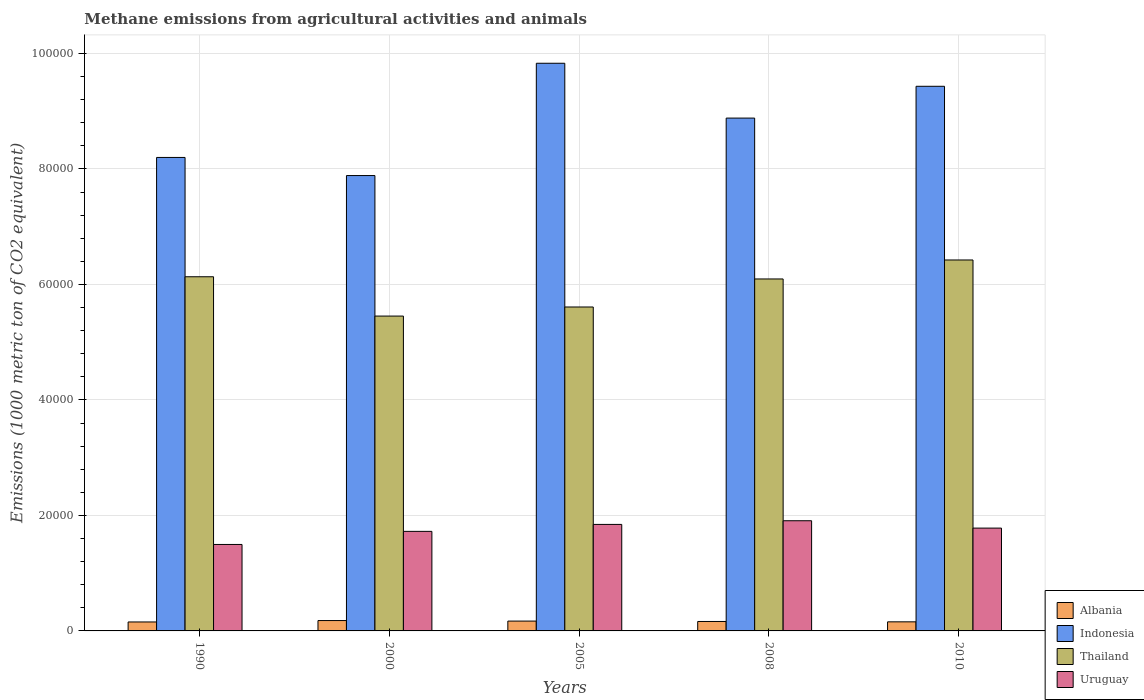How many different coloured bars are there?
Make the answer very short. 4. Are the number of bars per tick equal to the number of legend labels?
Provide a short and direct response. Yes. Are the number of bars on each tick of the X-axis equal?
Your answer should be very brief. Yes. How many bars are there on the 2nd tick from the left?
Your answer should be very brief. 4. How many bars are there on the 2nd tick from the right?
Your response must be concise. 4. What is the label of the 2nd group of bars from the left?
Provide a short and direct response. 2000. What is the amount of methane emitted in Thailand in 2005?
Offer a terse response. 5.61e+04. Across all years, what is the maximum amount of methane emitted in Albania?
Ensure brevity in your answer.  1794.6. Across all years, what is the minimum amount of methane emitted in Albania?
Ensure brevity in your answer.  1550.9. In which year was the amount of methane emitted in Uruguay minimum?
Keep it short and to the point. 1990. What is the total amount of methane emitted in Indonesia in the graph?
Offer a terse response. 4.42e+05. What is the difference between the amount of methane emitted in Thailand in 2005 and that in 2010?
Your answer should be very brief. -8141. What is the difference between the amount of methane emitted in Albania in 2010 and the amount of methane emitted in Thailand in 2005?
Keep it short and to the point. -5.45e+04. What is the average amount of methane emitted in Uruguay per year?
Provide a short and direct response. 1.75e+04. In the year 1990, what is the difference between the amount of methane emitted in Uruguay and amount of methane emitted in Albania?
Make the answer very short. 1.34e+04. In how many years, is the amount of methane emitted in Thailand greater than 80000 1000 metric ton?
Provide a succinct answer. 0. What is the ratio of the amount of methane emitted in Indonesia in 2000 to that in 2010?
Make the answer very short. 0.84. Is the amount of methane emitted in Albania in 2005 less than that in 2008?
Your response must be concise. No. What is the difference between the highest and the second highest amount of methane emitted in Albania?
Make the answer very short. 91.7. What is the difference between the highest and the lowest amount of methane emitted in Uruguay?
Make the answer very short. 4108.2. In how many years, is the amount of methane emitted in Albania greater than the average amount of methane emitted in Albania taken over all years?
Your answer should be compact. 2. Is the sum of the amount of methane emitted in Albania in 2005 and 2010 greater than the maximum amount of methane emitted in Uruguay across all years?
Your response must be concise. No. What does the 1st bar from the left in 2010 represents?
Offer a very short reply. Albania. What does the 4th bar from the right in 1990 represents?
Your response must be concise. Albania. Is it the case that in every year, the sum of the amount of methane emitted in Uruguay and amount of methane emitted in Albania is greater than the amount of methane emitted in Indonesia?
Ensure brevity in your answer.  No. How many bars are there?
Your answer should be compact. 20. How many years are there in the graph?
Give a very brief answer. 5. Does the graph contain grids?
Provide a succinct answer. Yes. How many legend labels are there?
Offer a terse response. 4. How are the legend labels stacked?
Your answer should be compact. Vertical. What is the title of the graph?
Offer a very short reply. Methane emissions from agricultural activities and animals. Does "Switzerland" appear as one of the legend labels in the graph?
Ensure brevity in your answer.  No. What is the label or title of the Y-axis?
Your answer should be compact. Emissions (1000 metric ton of CO2 equivalent). What is the Emissions (1000 metric ton of CO2 equivalent) in Albania in 1990?
Make the answer very short. 1550.9. What is the Emissions (1000 metric ton of CO2 equivalent) of Indonesia in 1990?
Ensure brevity in your answer.  8.20e+04. What is the Emissions (1000 metric ton of CO2 equivalent) of Thailand in 1990?
Keep it short and to the point. 6.13e+04. What is the Emissions (1000 metric ton of CO2 equivalent) of Uruguay in 1990?
Make the answer very short. 1.50e+04. What is the Emissions (1000 metric ton of CO2 equivalent) in Albania in 2000?
Make the answer very short. 1794.6. What is the Emissions (1000 metric ton of CO2 equivalent) of Indonesia in 2000?
Make the answer very short. 7.89e+04. What is the Emissions (1000 metric ton of CO2 equivalent) of Thailand in 2000?
Your answer should be very brief. 5.45e+04. What is the Emissions (1000 metric ton of CO2 equivalent) in Uruguay in 2000?
Make the answer very short. 1.72e+04. What is the Emissions (1000 metric ton of CO2 equivalent) of Albania in 2005?
Your answer should be compact. 1702.9. What is the Emissions (1000 metric ton of CO2 equivalent) in Indonesia in 2005?
Provide a short and direct response. 9.83e+04. What is the Emissions (1000 metric ton of CO2 equivalent) of Thailand in 2005?
Your answer should be compact. 5.61e+04. What is the Emissions (1000 metric ton of CO2 equivalent) in Uruguay in 2005?
Offer a terse response. 1.84e+04. What is the Emissions (1000 metric ton of CO2 equivalent) of Albania in 2008?
Offer a very short reply. 1635.8. What is the Emissions (1000 metric ton of CO2 equivalent) in Indonesia in 2008?
Your response must be concise. 8.88e+04. What is the Emissions (1000 metric ton of CO2 equivalent) in Thailand in 2008?
Your answer should be compact. 6.10e+04. What is the Emissions (1000 metric ton of CO2 equivalent) in Uruguay in 2008?
Give a very brief answer. 1.91e+04. What is the Emissions (1000 metric ton of CO2 equivalent) in Albania in 2010?
Your answer should be very brief. 1574.1. What is the Emissions (1000 metric ton of CO2 equivalent) in Indonesia in 2010?
Your answer should be compact. 9.43e+04. What is the Emissions (1000 metric ton of CO2 equivalent) in Thailand in 2010?
Keep it short and to the point. 6.42e+04. What is the Emissions (1000 metric ton of CO2 equivalent) of Uruguay in 2010?
Your response must be concise. 1.78e+04. Across all years, what is the maximum Emissions (1000 metric ton of CO2 equivalent) in Albania?
Provide a short and direct response. 1794.6. Across all years, what is the maximum Emissions (1000 metric ton of CO2 equivalent) in Indonesia?
Make the answer very short. 9.83e+04. Across all years, what is the maximum Emissions (1000 metric ton of CO2 equivalent) of Thailand?
Your response must be concise. 6.42e+04. Across all years, what is the maximum Emissions (1000 metric ton of CO2 equivalent) in Uruguay?
Ensure brevity in your answer.  1.91e+04. Across all years, what is the minimum Emissions (1000 metric ton of CO2 equivalent) in Albania?
Give a very brief answer. 1550.9. Across all years, what is the minimum Emissions (1000 metric ton of CO2 equivalent) in Indonesia?
Your answer should be compact. 7.89e+04. Across all years, what is the minimum Emissions (1000 metric ton of CO2 equivalent) of Thailand?
Keep it short and to the point. 5.45e+04. Across all years, what is the minimum Emissions (1000 metric ton of CO2 equivalent) of Uruguay?
Your response must be concise. 1.50e+04. What is the total Emissions (1000 metric ton of CO2 equivalent) of Albania in the graph?
Your answer should be compact. 8258.3. What is the total Emissions (1000 metric ton of CO2 equivalent) of Indonesia in the graph?
Offer a terse response. 4.42e+05. What is the total Emissions (1000 metric ton of CO2 equivalent) in Thailand in the graph?
Keep it short and to the point. 2.97e+05. What is the total Emissions (1000 metric ton of CO2 equivalent) of Uruguay in the graph?
Provide a succinct answer. 8.75e+04. What is the difference between the Emissions (1000 metric ton of CO2 equivalent) in Albania in 1990 and that in 2000?
Offer a very short reply. -243.7. What is the difference between the Emissions (1000 metric ton of CO2 equivalent) of Indonesia in 1990 and that in 2000?
Your answer should be very brief. 3136.2. What is the difference between the Emissions (1000 metric ton of CO2 equivalent) in Thailand in 1990 and that in 2000?
Ensure brevity in your answer.  6808.4. What is the difference between the Emissions (1000 metric ton of CO2 equivalent) of Uruguay in 1990 and that in 2000?
Make the answer very short. -2267.7. What is the difference between the Emissions (1000 metric ton of CO2 equivalent) in Albania in 1990 and that in 2005?
Ensure brevity in your answer.  -152. What is the difference between the Emissions (1000 metric ton of CO2 equivalent) in Indonesia in 1990 and that in 2005?
Give a very brief answer. -1.63e+04. What is the difference between the Emissions (1000 metric ton of CO2 equivalent) in Thailand in 1990 and that in 2005?
Provide a succinct answer. 5235.2. What is the difference between the Emissions (1000 metric ton of CO2 equivalent) in Uruguay in 1990 and that in 2005?
Keep it short and to the point. -3472.5. What is the difference between the Emissions (1000 metric ton of CO2 equivalent) in Albania in 1990 and that in 2008?
Give a very brief answer. -84.9. What is the difference between the Emissions (1000 metric ton of CO2 equivalent) of Indonesia in 1990 and that in 2008?
Your response must be concise. -6814.3. What is the difference between the Emissions (1000 metric ton of CO2 equivalent) in Thailand in 1990 and that in 2008?
Offer a very short reply. 381.9. What is the difference between the Emissions (1000 metric ton of CO2 equivalent) of Uruguay in 1990 and that in 2008?
Offer a terse response. -4108.2. What is the difference between the Emissions (1000 metric ton of CO2 equivalent) in Albania in 1990 and that in 2010?
Your response must be concise. -23.2. What is the difference between the Emissions (1000 metric ton of CO2 equivalent) of Indonesia in 1990 and that in 2010?
Offer a very short reply. -1.23e+04. What is the difference between the Emissions (1000 metric ton of CO2 equivalent) of Thailand in 1990 and that in 2010?
Your answer should be compact. -2905.8. What is the difference between the Emissions (1000 metric ton of CO2 equivalent) in Uruguay in 1990 and that in 2010?
Ensure brevity in your answer.  -2833.1. What is the difference between the Emissions (1000 metric ton of CO2 equivalent) of Albania in 2000 and that in 2005?
Give a very brief answer. 91.7. What is the difference between the Emissions (1000 metric ton of CO2 equivalent) in Indonesia in 2000 and that in 2005?
Your answer should be compact. -1.94e+04. What is the difference between the Emissions (1000 metric ton of CO2 equivalent) in Thailand in 2000 and that in 2005?
Give a very brief answer. -1573.2. What is the difference between the Emissions (1000 metric ton of CO2 equivalent) of Uruguay in 2000 and that in 2005?
Give a very brief answer. -1204.8. What is the difference between the Emissions (1000 metric ton of CO2 equivalent) in Albania in 2000 and that in 2008?
Give a very brief answer. 158.8. What is the difference between the Emissions (1000 metric ton of CO2 equivalent) of Indonesia in 2000 and that in 2008?
Give a very brief answer. -9950.5. What is the difference between the Emissions (1000 metric ton of CO2 equivalent) of Thailand in 2000 and that in 2008?
Your answer should be very brief. -6426.5. What is the difference between the Emissions (1000 metric ton of CO2 equivalent) in Uruguay in 2000 and that in 2008?
Provide a succinct answer. -1840.5. What is the difference between the Emissions (1000 metric ton of CO2 equivalent) of Albania in 2000 and that in 2010?
Offer a very short reply. 220.5. What is the difference between the Emissions (1000 metric ton of CO2 equivalent) of Indonesia in 2000 and that in 2010?
Provide a short and direct response. -1.55e+04. What is the difference between the Emissions (1000 metric ton of CO2 equivalent) in Thailand in 2000 and that in 2010?
Provide a succinct answer. -9714.2. What is the difference between the Emissions (1000 metric ton of CO2 equivalent) of Uruguay in 2000 and that in 2010?
Ensure brevity in your answer.  -565.4. What is the difference between the Emissions (1000 metric ton of CO2 equivalent) of Albania in 2005 and that in 2008?
Keep it short and to the point. 67.1. What is the difference between the Emissions (1000 metric ton of CO2 equivalent) in Indonesia in 2005 and that in 2008?
Give a very brief answer. 9496.1. What is the difference between the Emissions (1000 metric ton of CO2 equivalent) in Thailand in 2005 and that in 2008?
Make the answer very short. -4853.3. What is the difference between the Emissions (1000 metric ton of CO2 equivalent) in Uruguay in 2005 and that in 2008?
Ensure brevity in your answer.  -635.7. What is the difference between the Emissions (1000 metric ton of CO2 equivalent) in Albania in 2005 and that in 2010?
Your answer should be very brief. 128.8. What is the difference between the Emissions (1000 metric ton of CO2 equivalent) of Indonesia in 2005 and that in 2010?
Give a very brief answer. 3987.2. What is the difference between the Emissions (1000 metric ton of CO2 equivalent) in Thailand in 2005 and that in 2010?
Your answer should be very brief. -8141. What is the difference between the Emissions (1000 metric ton of CO2 equivalent) in Uruguay in 2005 and that in 2010?
Offer a terse response. 639.4. What is the difference between the Emissions (1000 metric ton of CO2 equivalent) in Albania in 2008 and that in 2010?
Keep it short and to the point. 61.7. What is the difference between the Emissions (1000 metric ton of CO2 equivalent) of Indonesia in 2008 and that in 2010?
Your answer should be very brief. -5508.9. What is the difference between the Emissions (1000 metric ton of CO2 equivalent) of Thailand in 2008 and that in 2010?
Ensure brevity in your answer.  -3287.7. What is the difference between the Emissions (1000 metric ton of CO2 equivalent) in Uruguay in 2008 and that in 2010?
Give a very brief answer. 1275.1. What is the difference between the Emissions (1000 metric ton of CO2 equivalent) in Albania in 1990 and the Emissions (1000 metric ton of CO2 equivalent) in Indonesia in 2000?
Your response must be concise. -7.73e+04. What is the difference between the Emissions (1000 metric ton of CO2 equivalent) in Albania in 1990 and the Emissions (1000 metric ton of CO2 equivalent) in Thailand in 2000?
Provide a succinct answer. -5.30e+04. What is the difference between the Emissions (1000 metric ton of CO2 equivalent) of Albania in 1990 and the Emissions (1000 metric ton of CO2 equivalent) of Uruguay in 2000?
Offer a very short reply. -1.57e+04. What is the difference between the Emissions (1000 metric ton of CO2 equivalent) of Indonesia in 1990 and the Emissions (1000 metric ton of CO2 equivalent) of Thailand in 2000?
Offer a terse response. 2.75e+04. What is the difference between the Emissions (1000 metric ton of CO2 equivalent) in Indonesia in 1990 and the Emissions (1000 metric ton of CO2 equivalent) in Uruguay in 2000?
Make the answer very short. 6.48e+04. What is the difference between the Emissions (1000 metric ton of CO2 equivalent) in Thailand in 1990 and the Emissions (1000 metric ton of CO2 equivalent) in Uruguay in 2000?
Make the answer very short. 4.41e+04. What is the difference between the Emissions (1000 metric ton of CO2 equivalent) in Albania in 1990 and the Emissions (1000 metric ton of CO2 equivalent) in Indonesia in 2005?
Make the answer very short. -9.68e+04. What is the difference between the Emissions (1000 metric ton of CO2 equivalent) in Albania in 1990 and the Emissions (1000 metric ton of CO2 equivalent) in Thailand in 2005?
Your response must be concise. -5.45e+04. What is the difference between the Emissions (1000 metric ton of CO2 equivalent) in Albania in 1990 and the Emissions (1000 metric ton of CO2 equivalent) in Uruguay in 2005?
Ensure brevity in your answer.  -1.69e+04. What is the difference between the Emissions (1000 metric ton of CO2 equivalent) of Indonesia in 1990 and the Emissions (1000 metric ton of CO2 equivalent) of Thailand in 2005?
Provide a short and direct response. 2.59e+04. What is the difference between the Emissions (1000 metric ton of CO2 equivalent) in Indonesia in 1990 and the Emissions (1000 metric ton of CO2 equivalent) in Uruguay in 2005?
Offer a very short reply. 6.36e+04. What is the difference between the Emissions (1000 metric ton of CO2 equivalent) in Thailand in 1990 and the Emissions (1000 metric ton of CO2 equivalent) in Uruguay in 2005?
Make the answer very short. 4.29e+04. What is the difference between the Emissions (1000 metric ton of CO2 equivalent) in Albania in 1990 and the Emissions (1000 metric ton of CO2 equivalent) in Indonesia in 2008?
Offer a very short reply. -8.73e+04. What is the difference between the Emissions (1000 metric ton of CO2 equivalent) of Albania in 1990 and the Emissions (1000 metric ton of CO2 equivalent) of Thailand in 2008?
Your answer should be compact. -5.94e+04. What is the difference between the Emissions (1000 metric ton of CO2 equivalent) in Albania in 1990 and the Emissions (1000 metric ton of CO2 equivalent) in Uruguay in 2008?
Make the answer very short. -1.75e+04. What is the difference between the Emissions (1000 metric ton of CO2 equivalent) of Indonesia in 1990 and the Emissions (1000 metric ton of CO2 equivalent) of Thailand in 2008?
Provide a short and direct response. 2.10e+04. What is the difference between the Emissions (1000 metric ton of CO2 equivalent) of Indonesia in 1990 and the Emissions (1000 metric ton of CO2 equivalent) of Uruguay in 2008?
Keep it short and to the point. 6.29e+04. What is the difference between the Emissions (1000 metric ton of CO2 equivalent) of Thailand in 1990 and the Emissions (1000 metric ton of CO2 equivalent) of Uruguay in 2008?
Provide a short and direct response. 4.23e+04. What is the difference between the Emissions (1000 metric ton of CO2 equivalent) in Albania in 1990 and the Emissions (1000 metric ton of CO2 equivalent) in Indonesia in 2010?
Provide a succinct answer. -9.28e+04. What is the difference between the Emissions (1000 metric ton of CO2 equivalent) in Albania in 1990 and the Emissions (1000 metric ton of CO2 equivalent) in Thailand in 2010?
Your answer should be very brief. -6.27e+04. What is the difference between the Emissions (1000 metric ton of CO2 equivalent) in Albania in 1990 and the Emissions (1000 metric ton of CO2 equivalent) in Uruguay in 2010?
Your answer should be very brief. -1.63e+04. What is the difference between the Emissions (1000 metric ton of CO2 equivalent) of Indonesia in 1990 and the Emissions (1000 metric ton of CO2 equivalent) of Thailand in 2010?
Give a very brief answer. 1.78e+04. What is the difference between the Emissions (1000 metric ton of CO2 equivalent) of Indonesia in 1990 and the Emissions (1000 metric ton of CO2 equivalent) of Uruguay in 2010?
Ensure brevity in your answer.  6.42e+04. What is the difference between the Emissions (1000 metric ton of CO2 equivalent) of Thailand in 1990 and the Emissions (1000 metric ton of CO2 equivalent) of Uruguay in 2010?
Offer a terse response. 4.35e+04. What is the difference between the Emissions (1000 metric ton of CO2 equivalent) of Albania in 2000 and the Emissions (1000 metric ton of CO2 equivalent) of Indonesia in 2005?
Make the answer very short. -9.65e+04. What is the difference between the Emissions (1000 metric ton of CO2 equivalent) of Albania in 2000 and the Emissions (1000 metric ton of CO2 equivalent) of Thailand in 2005?
Offer a terse response. -5.43e+04. What is the difference between the Emissions (1000 metric ton of CO2 equivalent) of Albania in 2000 and the Emissions (1000 metric ton of CO2 equivalent) of Uruguay in 2005?
Provide a short and direct response. -1.67e+04. What is the difference between the Emissions (1000 metric ton of CO2 equivalent) in Indonesia in 2000 and the Emissions (1000 metric ton of CO2 equivalent) in Thailand in 2005?
Your answer should be compact. 2.28e+04. What is the difference between the Emissions (1000 metric ton of CO2 equivalent) in Indonesia in 2000 and the Emissions (1000 metric ton of CO2 equivalent) in Uruguay in 2005?
Keep it short and to the point. 6.04e+04. What is the difference between the Emissions (1000 metric ton of CO2 equivalent) of Thailand in 2000 and the Emissions (1000 metric ton of CO2 equivalent) of Uruguay in 2005?
Make the answer very short. 3.61e+04. What is the difference between the Emissions (1000 metric ton of CO2 equivalent) in Albania in 2000 and the Emissions (1000 metric ton of CO2 equivalent) in Indonesia in 2008?
Make the answer very short. -8.70e+04. What is the difference between the Emissions (1000 metric ton of CO2 equivalent) of Albania in 2000 and the Emissions (1000 metric ton of CO2 equivalent) of Thailand in 2008?
Your answer should be compact. -5.92e+04. What is the difference between the Emissions (1000 metric ton of CO2 equivalent) of Albania in 2000 and the Emissions (1000 metric ton of CO2 equivalent) of Uruguay in 2008?
Offer a very short reply. -1.73e+04. What is the difference between the Emissions (1000 metric ton of CO2 equivalent) of Indonesia in 2000 and the Emissions (1000 metric ton of CO2 equivalent) of Thailand in 2008?
Provide a short and direct response. 1.79e+04. What is the difference between the Emissions (1000 metric ton of CO2 equivalent) in Indonesia in 2000 and the Emissions (1000 metric ton of CO2 equivalent) in Uruguay in 2008?
Offer a very short reply. 5.98e+04. What is the difference between the Emissions (1000 metric ton of CO2 equivalent) in Thailand in 2000 and the Emissions (1000 metric ton of CO2 equivalent) in Uruguay in 2008?
Provide a short and direct response. 3.54e+04. What is the difference between the Emissions (1000 metric ton of CO2 equivalent) in Albania in 2000 and the Emissions (1000 metric ton of CO2 equivalent) in Indonesia in 2010?
Your answer should be compact. -9.25e+04. What is the difference between the Emissions (1000 metric ton of CO2 equivalent) of Albania in 2000 and the Emissions (1000 metric ton of CO2 equivalent) of Thailand in 2010?
Make the answer very short. -6.24e+04. What is the difference between the Emissions (1000 metric ton of CO2 equivalent) in Albania in 2000 and the Emissions (1000 metric ton of CO2 equivalent) in Uruguay in 2010?
Provide a short and direct response. -1.60e+04. What is the difference between the Emissions (1000 metric ton of CO2 equivalent) of Indonesia in 2000 and the Emissions (1000 metric ton of CO2 equivalent) of Thailand in 2010?
Make the answer very short. 1.46e+04. What is the difference between the Emissions (1000 metric ton of CO2 equivalent) of Indonesia in 2000 and the Emissions (1000 metric ton of CO2 equivalent) of Uruguay in 2010?
Keep it short and to the point. 6.11e+04. What is the difference between the Emissions (1000 metric ton of CO2 equivalent) of Thailand in 2000 and the Emissions (1000 metric ton of CO2 equivalent) of Uruguay in 2010?
Give a very brief answer. 3.67e+04. What is the difference between the Emissions (1000 metric ton of CO2 equivalent) in Albania in 2005 and the Emissions (1000 metric ton of CO2 equivalent) in Indonesia in 2008?
Your response must be concise. -8.71e+04. What is the difference between the Emissions (1000 metric ton of CO2 equivalent) of Albania in 2005 and the Emissions (1000 metric ton of CO2 equivalent) of Thailand in 2008?
Give a very brief answer. -5.92e+04. What is the difference between the Emissions (1000 metric ton of CO2 equivalent) of Albania in 2005 and the Emissions (1000 metric ton of CO2 equivalent) of Uruguay in 2008?
Provide a succinct answer. -1.74e+04. What is the difference between the Emissions (1000 metric ton of CO2 equivalent) in Indonesia in 2005 and the Emissions (1000 metric ton of CO2 equivalent) in Thailand in 2008?
Your answer should be very brief. 3.74e+04. What is the difference between the Emissions (1000 metric ton of CO2 equivalent) of Indonesia in 2005 and the Emissions (1000 metric ton of CO2 equivalent) of Uruguay in 2008?
Provide a short and direct response. 7.92e+04. What is the difference between the Emissions (1000 metric ton of CO2 equivalent) in Thailand in 2005 and the Emissions (1000 metric ton of CO2 equivalent) in Uruguay in 2008?
Your response must be concise. 3.70e+04. What is the difference between the Emissions (1000 metric ton of CO2 equivalent) of Albania in 2005 and the Emissions (1000 metric ton of CO2 equivalent) of Indonesia in 2010?
Provide a short and direct response. -9.26e+04. What is the difference between the Emissions (1000 metric ton of CO2 equivalent) in Albania in 2005 and the Emissions (1000 metric ton of CO2 equivalent) in Thailand in 2010?
Provide a short and direct response. -6.25e+04. What is the difference between the Emissions (1000 metric ton of CO2 equivalent) of Albania in 2005 and the Emissions (1000 metric ton of CO2 equivalent) of Uruguay in 2010?
Keep it short and to the point. -1.61e+04. What is the difference between the Emissions (1000 metric ton of CO2 equivalent) in Indonesia in 2005 and the Emissions (1000 metric ton of CO2 equivalent) in Thailand in 2010?
Offer a terse response. 3.41e+04. What is the difference between the Emissions (1000 metric ton of CO2 equivalent) of Indonesia in 2005 and the Emissions (1000 metric ton of CO2 equivalent) of Uruguay in 2010?
Offer a very short reply. 8.05e+04. What is the difference between the Emissions (1000 metric ton of CO2 equivalent) of Thailand in 2005 and the Emissions (1000 metric ton of CO2 equivalent) of Uruguay in 2010?
Make the answer very short. 3.83e+04. What is the difference between the Emissions (1000 metric ton of CO2 equivalent) in Albania in 2008 and the Emissions (1000 metric ton of CO2 equivalent) in Indonesia in 2010?
Keep it short and to the point. -9.27e+04. What is the difference between the Emissions (1000 metric ton of CO2 equivalent) of Albania in 2008 and the Emissions (1000 metric ton of CO2 equivalent) of Thailand in 2010?
Keep it short and to the point. -6.26e+04. What is the difference between the Emissions (1000 metric ton of CO2 equivalent) of Albania in 2008 and the Emissions (1000 metric ton of CO2 equivalent) of Uruguay in 2010?
Provide a succinct answer. -1.62e+04. What is the difference between the Emissions (1000 metric ton of CO2 equivalent) in Indonesia in 2008 and the Emissions (1000 metric ton of CO2 equivalent) in Thailand in 2010?
Your answer should be compact. 2.46e+04. What is the difference between the Emissions (1000 metric ton of CO2 equivalent) of Indonesia in 2008 and the Emissions (1000 metric ton of CO2 equivalent) of Uruguay in 2010?
Your answer should be compact. 7.10e+04. What is the difference between the Emissions (1000 metric ton of CO2 equivalent) of Thailand in 2008 and the Emissions (1000 metric ton of CO2 equivalent) of Uruguay in 2010?
Provide a short and direct response. 4.31e+04. What is the average Emissions (1000 metric ton of CO2 equivalent) in Albania per year?
Offer a very short reply. 1651.66. What is the average Emissions (1000 metric ton of CO2 equivalent) of Indonesia per year?
Provide a short and direct response. 8.85e+04. What is the average Emissions (1000 metric ton of CO2 equivalent) in Thailand per year?
Offer a terse response. 5.94e+04. What is the average Emissions (1000 metric ton of CO2 equivalent) of Uruguay per year?
Ensure brevity in your answer.  1.75e+04. In the year 1990, what is the difference between the Emissions (1000 metric ton of CO2 equivalent) in Albania and Emissions (1000 metric ton of CO2 equivalent) in Indonesia?
Make the answer very short. -8.04e+04. In the year 1990, what is the difference between the Emissions (1000 metric ton of CO2 equivalent) of Albania and Emissions (1000 metric ton of CO2 equivalent) of Thailand?
Give a very brief answer. -5.98e+04. In the year 1990, what is the difference between the Emissions (1000 metric ton of CO2 equivalent) in Albania and Emissions (1000 metric ton of CO2 equivalent) in Uruguay?
Give a very brief answer. -1.34e+04. In the year 1990, what is the difference between the Emissions (1000 metric ton of CO2 equivalent) in Indonesia and Emissions (1000 metric ton of CO2 equivalent) in Thailand?
Your answer should be compact. 2.07e+04. In the year 1990, what is the difference between the Emissions (1000 metric ton of CO2 equivalent) of Indonesia and Emissions (1000 metric ton of CO2 equivalent) of Uruguay?
Provide a short and direct response. 6.70e+04. In the year 1990, what is the difference between the Emissions (1000 metric ton of CO2 equivalent) of Thailand and Emissions (1000 metric ton of CO2 equivalent) of Uruguay?
Your answer should be very brief. 4.64e+04. In the year 2000, what is the difference between the Emissions (1000 metric ton of CO2 equivalent) in Albania and Emissions (1000 metric ton of CO2 equivalent) in Indonesia?
Provide a short and direct response. -7.71e+04. In the year 2000, what is the difference between the Emissions (1000 metric ton of CO2 equivalent) of Albania and Emissions (1000 metric ton of CO2 equivalent) of Thailand?
Your answer should be compact. -5.27e+04. In the year 2000, what is the difference between the Emissions (1000 metric ton of CO2 equivalent) in Albania and Emissions (1000 metric ton of CO2 equivalent) in Uruguay?
Your answer should be very brief. -1.54e+04. In the year 2000, what is the difference between the Emissions (1000 metric ton of CO2 equivalent) in Indonesia and Emissions (1000 metric ton of CO2 equivalent) in Thailand?
Offer a terse response. 2.43e+04. In the year 2000, what is the difference between the Emissions (1000 metric ton of CO2 equivalent) in Indonesia and Emissions (1000 metric ton of CO2 equivalent) in Uruguay?
Your response must be concise. 6.16e+04. In the year 2000, what is the difference between the Emissions (1000 metric ton of CO2 equivalent) of Thailand and Emissions (1000 metric ton of CO2 equivalent) of Uruguay?
Make the answer very short. 3.73e+04. In the year 2005, what is the difference between the Emissions (1000 metric ton of CO2 equivalent) of Albania and Emissions (1000 metric ton of CO2 equivalent) of Indonesia?
Make the answer very short. -9.66e+04. In the year 2005, what is the difference between the Emissions (1000 metric ton of CO2 equivalent) in Albania and Emissions (1000 metric ton of CO2 equivalent) in Thailand?
Ensure brevity in your answer.  -5.44e+04. In the year 2005, what is the difference between the Emissions (1000 metric ton of CO2 equivalent) of Albania and Emissions (1000 metric ton of CO2 equivalent) of Uruguay?
Offer a terse response. -1.67e+04. In the year 2005, what is the difference between the Emissions (1000 metric ton of CO2 equivalent) of Indonesia and Emissions (1000 metric ton of CO2 equivalent) of Thailand?
Your response must be concise. 4.22e+04. In the year 2005, what is the difference between the Emissions (1000 metric ton of CO2 equivalent) of Indonesia and Emissions (1000 metric ton of CO2 equivalent) of Uruguay?
Your response must be concise. 7.99e+04. In the year 2005, what is the difference between the Emissions (1000 metric ton of CO2 equivalent) in Thailand and Emissions (1000 metric ton of CO2 equivalent) in Uruguay?
Make the answer very short. 3.77e+04. In the year 2008, what is the difference between the Emissions (1000 metric ton of CO2 equivalent) in Albania and Emissions (1000 metric ton of CO2 equivalent) in Indonesia?
Make the answer very short. -8.72e+04. In the year 2008, what is the difference between the Emissions (1000 metric ton of CO2 equivalent) of Albania and Emissions (1000 metric ton of CO2 equivalent) of Thailand?
Offer a very short reply. -5.93e+04. In the year 2008, what is the difference between the Emissions (1000 metric ton of CO2 equivalent) of Albania and Emissions (1000 metric ton of CO2 equivalent) of Uruguay?
Offer a very short reply. -1.74e+04. In the year 2008, what is the difference between the Emissions (1000 metric ton of CO2 equivalent) in Indonesia and Emissions (1000 metric ton of CO2 equivalent) in Thailand?
Give a very brief answer. 2.79e+04. In the year 2008, what is the difference between the Emissions (1000 metric ton of CO2 equivalent) of Indonesia and Emissions (1000 metric ton of CO2 equivalent) of Uruguay?
Keep it short and to the point. 6.97e+04. In the year 2008, what is the difference between the Emissions (1000 metric ton of CO2 equivalent) of Thailand and Emissions (1000 metric ton of CO2 equivalent) of Uruguay?
Keep it short and to the point. 4.19e+04. In the year 2010, what is the difference between the Emissions (1000 metric ton of CO2 equivalent) of Albania and Emissions (1000 metric ton of CO2 equivalent) of Indonesia?
Make the answer very short. -9.27e+04. In the year 2010, what is the difference between the Emissions (1000 metric ton of CO2 equivalent) in Albania and Emissions (1000 metric ton of CO2 equivalent) in Thailand?
Give a very brief answer. -6.27e+04. In the year 2010, what is the difference between the Emissions (1000 metric ton of CO2 equivalent) of Albania and Emissions (1000 metric ton of CO2 equivalent) of Uruguay?
Your response must be concise. -1.62e+04. In the year 2010, what is the difference between the Emissions (1000 metric ton of CO2 equivalent) in Indonesia and Emissions (1000 metric ton of CO2 equivalent) in Thailand?
Give a very brief answer. 3.01e+04. In the year 2010, what is the difference between the Emissions (1000 metric ton of CO2 equivalent) of Indonesia and Emissions (1000 metric ton of CO2 equivalent) of Uruguay?
Provide a succinct answer. 7.65e+04. In the year 2010, what is the difference between the Emissions (1000 metric ton of CO2 equivalent) in Thailand and Emissions (1000 metric ton of CO2 equivalent) in Uruguay?
Ensure brevity in your answer.  4.64e+04. What is the ratio of the Emissions (1000 metric ton of CO2 equivalent) in Albania in 1990 to that in 2000?
Offer a very short reply. 0.86. What is the ratio of the Emissions (1000 metric ton of CO2 equivalent) in Indonesia in 1990 to that in 2000?
Offer a very short reply. 1.04. What is the ratio of the Emissions (1000 metric ton of CO2 equivalent) of Thailand in 1990 to that in 2000?
Your answer should be very brief. 1.12. What is the ratio of the Emissions (1000 metric ton of CO2 equivalent) of Uruguay in 1990 to that in 2000?
Provide a short and direct response. 0.87. What is the ratio of the Emissions (1000 metric ton of CO2 equivalent) in Albania in 1990 to that in 2005?
Provide a short and direct response. 0.91. What is the ratio of the Emissions (1000 metric ton of CO2 equivalent) of Indonesia in 1990 to that in 2005?
Provide a short and direct response. 0.83. What is the ratio of the Emissions (1000 metric ton of CO2 equivalent) of Thailand in 1990 to that in 2005?
Your answer should be compact. 1.09. What is the ratio of the Emissions (1000 metric ton of CO2 equivalent) in Uruguay in 1990 to that in 2005?
Keep it short and to the point. 0.81. What is the ratio of the Emissions (1000 metric ton of CO2 equivalent) in Albania in 1990 to that in 2008?
Your answer should be very brief. 0.95. What is the ratio of the Emissions (1000 metric ton of CO2 equivalent) of Indonesia in 1990 to that in 2008?
Keep it short and to the point. 0.92. What is the ratio of the Emissions (1000 metric ton of CO2 equivalent) of Uruguay in 1990 to that in 2008?
Your response must be concise. 0.78. What is the ratio of the Emissions (1000 metric ton of CO2 equivalent) of Albania in 1990 to that in 2010?
Offer a very short reply. 0.99. What is the ratio of the Emissions (1000 metric ton of CO2 equivalent) of Indonesia in 1990 to that in 2010?
Your answer should be very brief. 0.87. What is the ratio of the Emissions (1000 metric ton of CO2 equivalent) in Thailand in 1990 to that in 2010?
Make the answer very short. 0.95. What is the ratio of the Emissions (1000 metric ton of CO2 equivalent) in Uruguay in 1990 to that in 2010?
Your response must be concise. 0.84. What is the ratio of the Emissions (1000 metric ton of CO2 equivalent) of Albania in 2000 to that in 2005?
Provide a succinct answer. 1.05. What is the ratio of the Emissions (1000 metric ton of CO2 equivalent) of Indonesia in 2000 to that in 2005?
Your response must be concise. 0.8. What is the ratio of the Emissions (1000 metric ton of CO2 equivalent) in Thailand in 2000 to that in 2005?
Provide a succinct answer. 0.97. What is the ratio of the Emissions (1000 metric ton of CO2 equivalent) of Uruguay in 2000 to that in 2005?
Your answer should be very brief. 0.93. What is the ratio of the Emissions (1000 metric ton of CO2 equivalent) in Albania in 2000 to that in 2008?
Ensure brevity in your answer.  1.1. What is the ratio of the Emissions (1000 metric ton of CO2 equivalent) of Indonesia in 2000 to that in 2008?
Your answer should be compact. 0.89. What is the ratio of the Emissions (1000 metric ton of CO2 equivalent) in Thailand in 2000 to that in 2008?
Your answer should be very brief. 0.89. What is the ratio of the Emissions (1000 metric ton of CO2 equivalent) in Uruguay in 2000 to that in 2008?
Offer a terse response. 0.9. What is the ratio of the Emissions (1000 metric ton of CO2 equivalent) in Albania in 2000 to that in 2010?
Ensure brevity in your answer.  1.14. What is the ratio of the Emissions (1000 metric ton of CO2 equivalent) of Indonesia in 2000 to that in 2010?
Ensure brevity in your answer.  0.84. What is the ratio of the Emissions (1000 metric ton of CO2 equivalent) in Thailand in 2000 to that in 2010?
Your answer should be very brief. 0.85. What is the ratio of the Emissions (1000 metric ton of CO2 equivalent) in Uruguay in 2000 to that in 2010?
Your response must be concise. 0.97. What is the ratio of the Emissions (1000 metric ton of CO2 equivalent) in Albania in 2005 to that in 2008?
Provide a succinct answer. 1.04. What is the ratio of the Emissions (1000 metric ton of CO2 equivalent) of Indonesia in 2005 to that in 2008?
Ensure brevity in your answer.  1.11. What is the ratio of the Emissions (1000 metric ton of CO2 equivalent) in Thailand in 2005 to that in 2008?
Your response must be concise. 0.92. What is the ratio of the Emissions (1000 metric ton of CO2 equivalent) of Uruguay in 2005 to that in 2008?
Your answer should be compact. 0.97. What is the ratio of the Emissions (1000 metric ton of CO2 equivalent) of Albania in 2005 to that in 2010?
Your response must be concise. 1.08. What is the ratio of the Emissions (1000 metric ton of CO2 equivalent) of Indonesia in 2005 to that in 2010?
Make the answer very short. 1.04. What is the ratio of the Emissions (1000 metric ton of CO2 equivalent) in Thailand in 2005 to that in 2010?
Your answer should be very brief. 0.87. What is the ratio of the Emissions (1000 metric ton of CO2 equivalent) in Uruguay in 2005 to that in 2010?
Make the answer very short. 1.04. What is the ratio of the Emissions (1000 metric ton of CO2 equivalent) of Albania in 2008 to that in 2010?
Ensure brevity in your answer.  1.04. What is the ratio of the Emissions (1000 metric ton of CO2 equivalent) in Indonesia in 2008 to that in 2010?
Offer a very short reply. 0.94. What is the ratio of the Emissions (1000 metric ton of CO2 equivalent) in Thailand in 2008 to that in 2010?
Your response must be concise. 0.95. What is the ratio of the Emissions (1000 metric ton of CO2 equivalent) of Uruguay in 2008 to that in 2010?
Your response must be concise. 1.07. What is the difference between the highest and the second highest Emissions (1000 metric ton of CO2 equivalent) in Albania?
Give a very brief answer. 91.7. What is the difference between the highest and the second highest Emissions (1000 metric ton of CO2 equivalent) of Indonesia?
Ensure brevity in your answer.  3987.2. What is the difference between the highest and the second highest Emissions (1000 metric ton of CO2 equivalent) of Thailand?
Offer a terse response. 2905.8. What is the difference between the highest and the second highest Emissions (1000 metric ton of CO2 equivalent) in Uruguay?
Give a very brief answer. 635.7. What is the difference between the highest and the lowest Emissions (1000 metric ton of CO2 equivalent) of Albania?
Offer a very short reply. 243.7. What is the difference between the highest and the lowest Emissions (1000 metric ton of CO2 equivalent) of Indonesia?
Make the answer very short. 1.94e+04. What is the difference between the highest and the lowest Emissions (1000 metric ton of CO2 equivalent) of Thailand?
Your answer should be compact. 9714.2. What is the difference between the highest and the lowest Emissions (1000 metric ton of CO2 equivalent) of Uruguay?
Your response must be concise. 4108.2. 